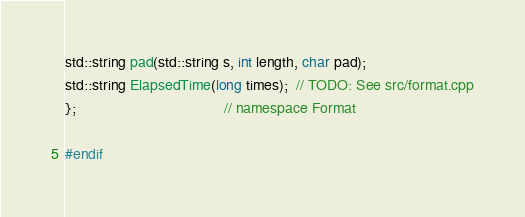Convert code to text. <code><loc_0><loc_0><loc_500><loc_500><_C_>std::string pad(std::string s, int length, char pad);
std::string ElapsedTime(long times);  // TODO: See src/format.cpp
};                                    // namespace Format

#endif</code> 